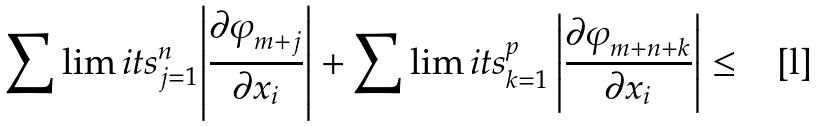<formula> <loc_0><loc_0><loc_500><loc_500>\sum \lim i t s _ { j = 1 } ^ { n } { \left | \frac { { \partial \varphi } _ { m + j } } { { \partial x } _ { i } } \right | + \sum \lim i t s _ { k = 1 } ^ { p } \left | \frac { { \partial \varphi } _ { m + n + k } } { { \partial x } _ { i } } \right | } \leq</formula> 